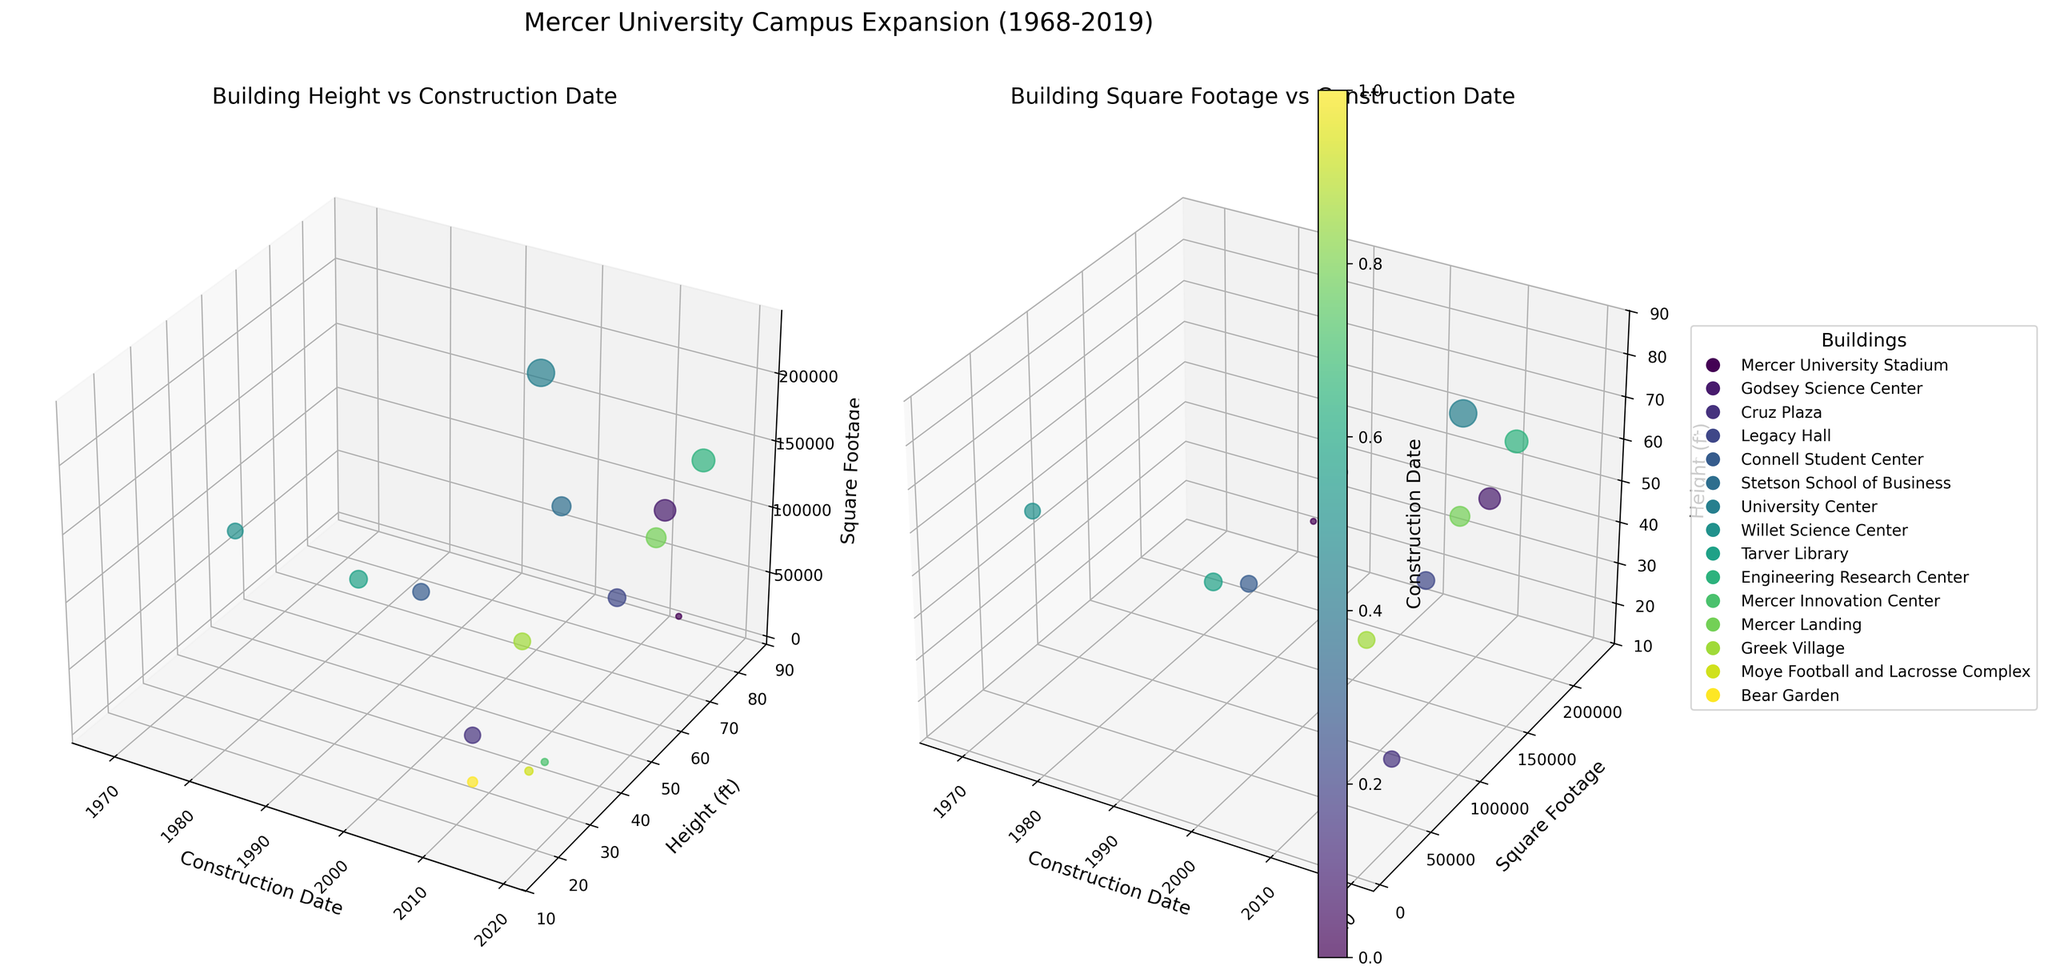How does the height of the Mercer University Stadium compare to the Godsey Science Center? To compare the heights, look for the data points representing the buildings and refer to the y-axis (height). The Mercer University Stadium has a height of 85 feet, while the Godsey Science Center is 65 feet tall.
Answer: Mercer University Stadium is taller by 20 feet What is the relationship between construction date and building height in the first plot? Examine the relationship by observing the trend along the x-axis (construction date) and y-axis (height) in the first subplot. The plot generally shows a positive correlation, indicating that building heights increase over recent years.
Answer: Positive correlation Which building occupies the largest square footage according to the second plot? Look at the z-axis in the second subplot, representing square footage, and identify the tallest point. The University Center, with 230,000 square feet, occupies the largest area.
Answer: University Center What is the average square footage of buildings constructed after 2000? First identify buildings constructed after 2000, then calculate the sum of their square footages and divide by the number of buildings. Post-2000 buildings are: Mercer University Stadium (10,000), Godsey Science Center (142,000), Legacy Hall (95,000), Engineering Research Center (160,000), Stetson School of Business (110,000), Mercer Landing (120,000), Mercer Innovation Center (15,000), and Moye Football and Lacrosse Complex (20,000). The total is 672,000 sq. ft., and there are 8 buildings, so the average is 672,000 / 8 = 84,000.
Answer: 84,000 sq. ft Which building has the earliest construction date and what is its height? In both subplots, locate the point corresponding to the earliest construction date on the x-axis. Willet Science Center was constructed in 1968 and has a height of 50 feet.
Answer: Willet Science Center, 50 feet Which building was constructed in 2015 and what are its height and square footage? Locate the data point for 2015 in both subplots and trace its y and z values. In 2015, Mercer Innovation Center and Moye Football and Lacrosse Complex were constructed; Mercer Innovation Center is 35 feet tall with 15,000 sq. ft., while Moye is 30 feet tall with 20,000 sq. ft.
Answer: Mercer Innovation Center: 35 feet, 15,000 sq. ft.; Moye: 30 feet, 20,000 sq. ft What is the height and square footage of the buildings constructed before 1980? Look for buildings with construction dates earlier than 1980 and refer to their y (height) and z (square footage) values. Willet Science Center (1968) has a height of 50 feet and 75,000 sq. ft., Tarver Library (1989) has 40 feet height and 95,000 sq. ft.
Answer: Willet Science Center: 50 feet, 75,000 sq. ft.; Tarver Library: 40 feet, 95,000 sq. ft How does square footage change over the years in the second plot? Observe the trend in the second subplot for the z-axis (square footage) as it relates to x-axis (construction date). Generally, the square footage shows an increasing trend, indicating larger buildings in recent years.
Answer: Increasing trend What is the median height of all buildings? List all building heights and find the median: [15, 20, 30, 35, 40, 40, 45, 50, 55, 60, 65, 65, 70, 75, 85]. The middle value in this ordered list is 50.
Answer: 50 feet 